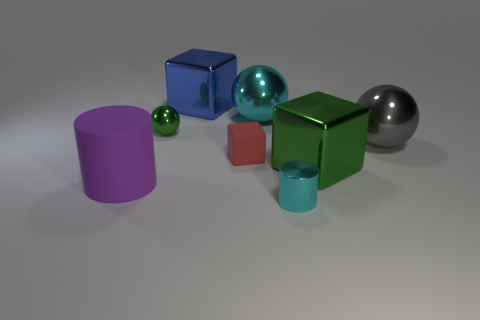Which object in the image appears to be the largest? The largest object in this image is the green cube. Its overall dimensions, relative to the other objects in sight, appear greater, making it the most sizable item displayed in this particular arrangement. How does the size of the green cube compare to the smallest object? In comparison to the smallest object, which seems to be the tiny red cube adjacent to the green shiny block, the green cube is considerably larger. If the red cube were to be a reference, it could likely fit multiple times into the volume taken up by the green cube. 